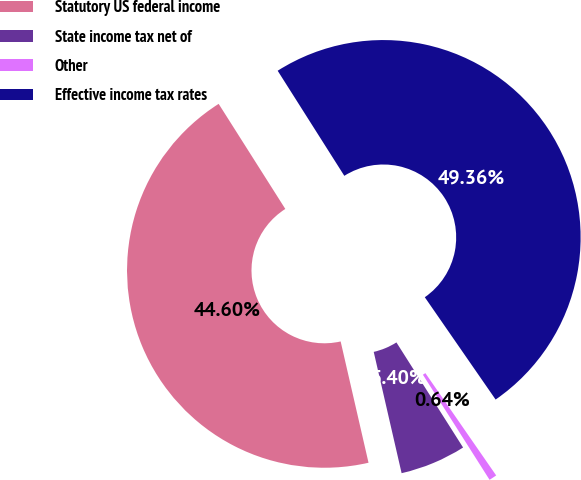<chart> <loc_0><loc_0><loc_500><loc_500><pie_chart><fcel>Statutory US federal income<fcel>State income tax net of<fcel>Other<fcel>Effective income tax rates<nl><fcel>44.6%<fcel>5.4%<fcel>0.64%<fcel>49.36%<nl></chart> 